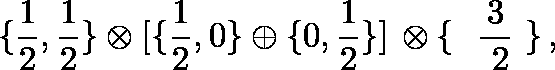<formula> <loc_0><loc_0><loc_500><loc_500>\{ { \frac { 1 } { 2 } } , { \frac { 1 } { 2 } } \} \otimes [ \{ { \frac { 1 } { 2 } } , 0 \} \oplus \{ 0 , { \frac { 1 } { 2 } } \} ] \, \otimes \{ \boldmath { \frac { 3 } { 2 } } \} \, ,</formula> 